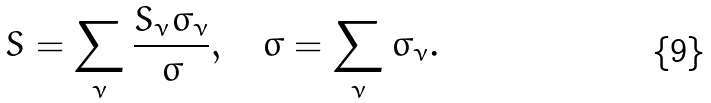<formula> <loc_0><loc_0><loc_500><loc_500>S = \sum _ { \nu } \frac { S _ { \nu } \sigma _ { \nu } } { \sigma } , \quad \sigma = \sum _ { \nu } \sigma _ { \nu } .</formula> 